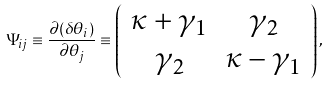Convert formula to latex. <formula><loc_0><loc_0><loc_500><loc_500>\Psi _ { i j } \equiv \frac { \partial ( \delta \theta _ { i } ) } { \partial \theta _ { j } } \equiv \left ( \begin{array} { c c } \kappa + \gamma _ { 1 } & \gamma _ { 2 } \\ \gamma _ { 2 } & \kappa - \gamma _ { 1 } \\ \end{array} \right ) ,</formula> 